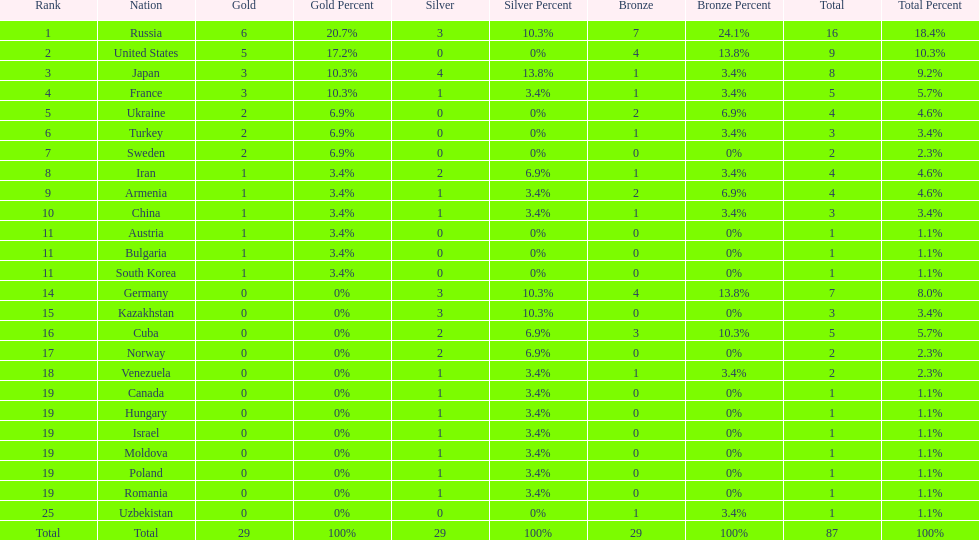Which nation has one gold medal but zero in both silver and bronze? Austria. 